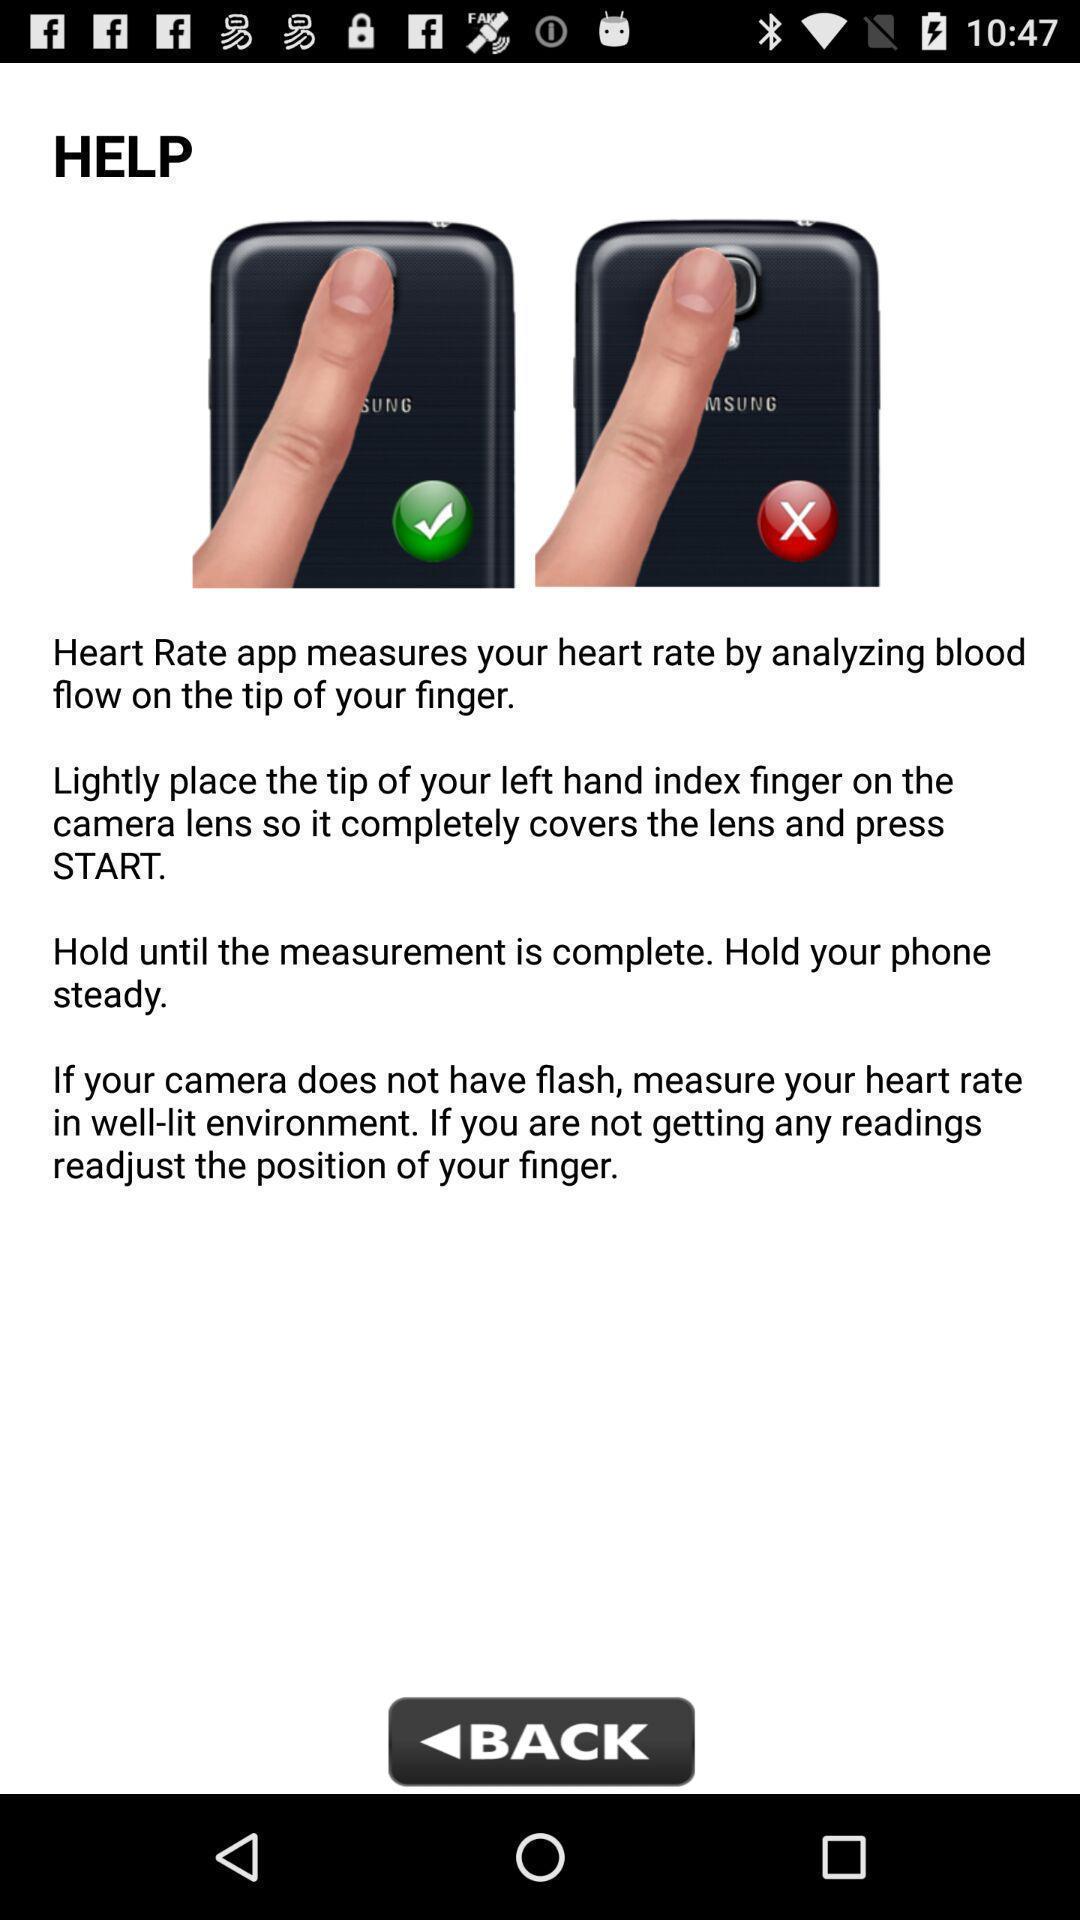What details can you identify in this image? Social app for the help to analyzing blood. 